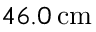Convert formula to latex. <formula><loc_0><loc_0><loc_500><loc_500>4 6 . 0 \, c m</formula> 